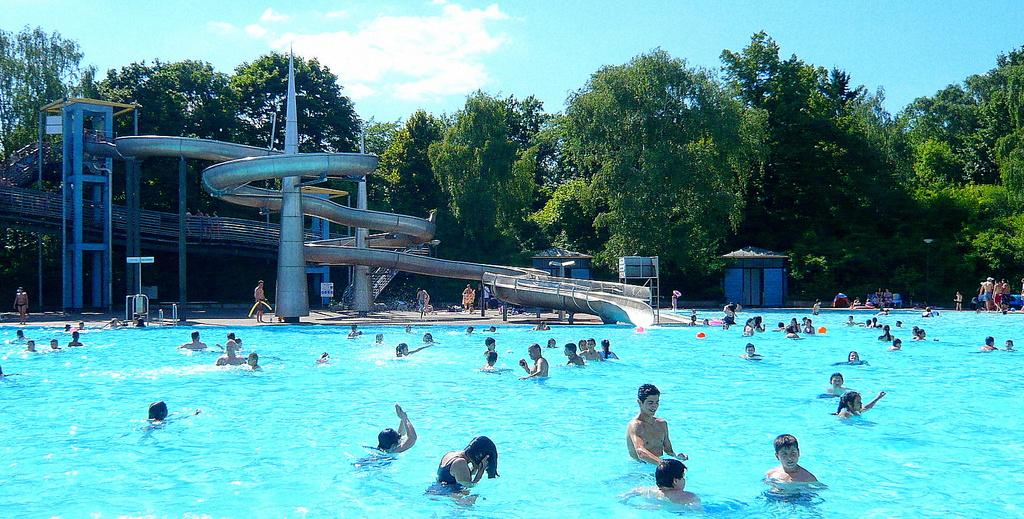What is the main feature in the image? There is a pool in the image. What are the people in the image doing? There are many people swimming in the pool. What can be seen on the left side of the image? There is a water slide on the left side of the image. What is visible in the background of the image? Trees are visible in the background of the image. What is visible at the top of the image? The sky is visible in the image, and clouds are present in the sky. What type of voice can be heard coming from the kittens in the image? There are no kittens present in the image, so it is not possible to determine what type of voice might be heard. 